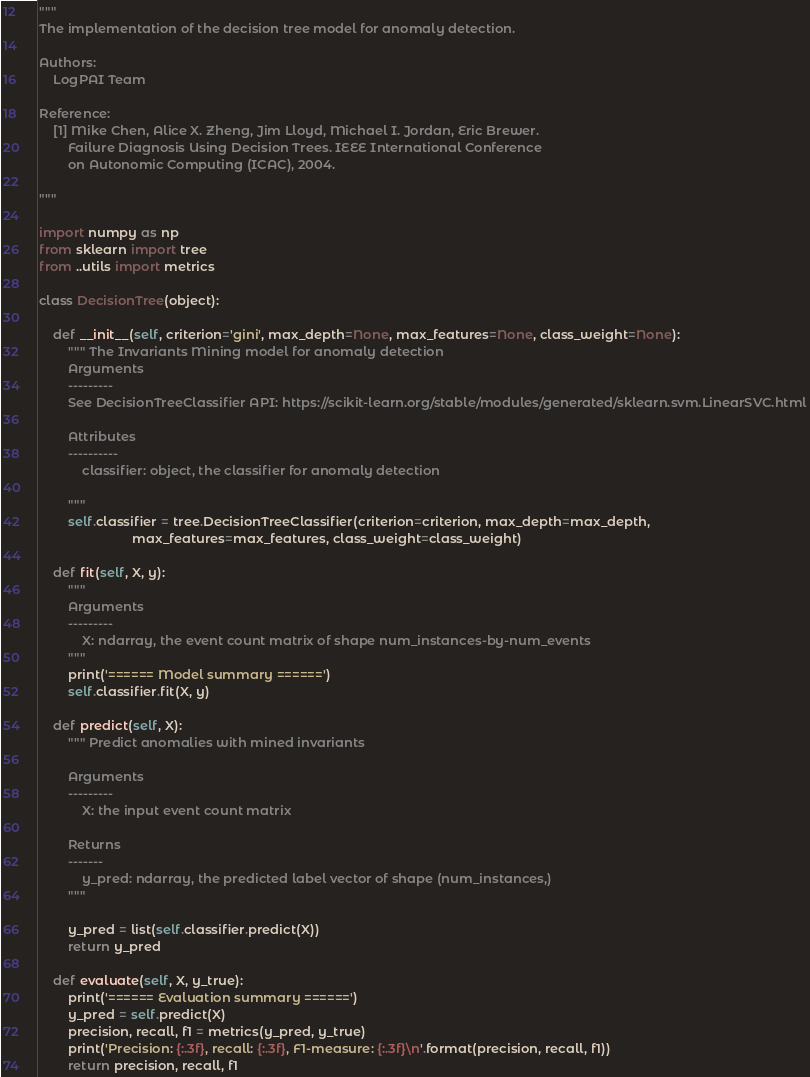Convert code to text. <code><loc_0><loc_0><loc_500><loc_500><_Python_>"""
The implementation of the decision tree model for anomaly detection.

Authors: 
    LogPAI Team

Reference: 
    [1] Mike Chen, Alice X. Zheng, Jim Lloyd, Michael I. Jordan, Eric Brewer. 
        Failure Diagnosis Using Decision Trees. IEEE International Conference 
        on Autonomic Computing (ICAC), 2004.

"""

import numpy as np
from sklearn import tree
from ..utils import metrics

class DecisionTree(object):

    def __init__(self, criterion='gini', max_depth=None, max_features=None, class_weight=None):
        """ The Invariants Mining model for anomaly detection
        Arguments
        ---------
        See DecisionTreeClassifier API: https://scikit-learn.org/stable/modules/generated/sklearn.svm.LinearSVC.html

        Attributes
        ----------
            classifier: object, the classifier for anomaly detection

        """
        self.classifier = tree.DecisionTreeClassifier(criterion=criterion, max_depth=max_depth,
                          max_features=max_features, class_weight=class_weight)

    def fit(self, X, y):
        """
        Arguments
        ---------
            X: ndarray, the event count matrix of shape num_instances-by-num_events
        """
        print('====== Model summary ======')
        self.classifier.fit(X, y)

    def predict(self, X):
        """ Predict anomalies with mined invariants

        Arguments
        ---------
            X: the input event count matrix

        Returns
        -------
            y_pred: ndarray, the predicted label vector of shape (num_instances,)
        """
        
        y_pred = list(self.classifier.predict(X))
        return y_pred

    def evaluate(self, X, y_true):
        print('====== Evaluation summary ======')
        y_pred = self.predict(X)
        precision, recall, f1 = metrics(y_pred, y_true)
        print('Precision: {:.3f}, recall: {:.3f}, F1-measure: {:.3f}\n'.format(precision, recall, f1))
        return precision, recall, f1
</code> 